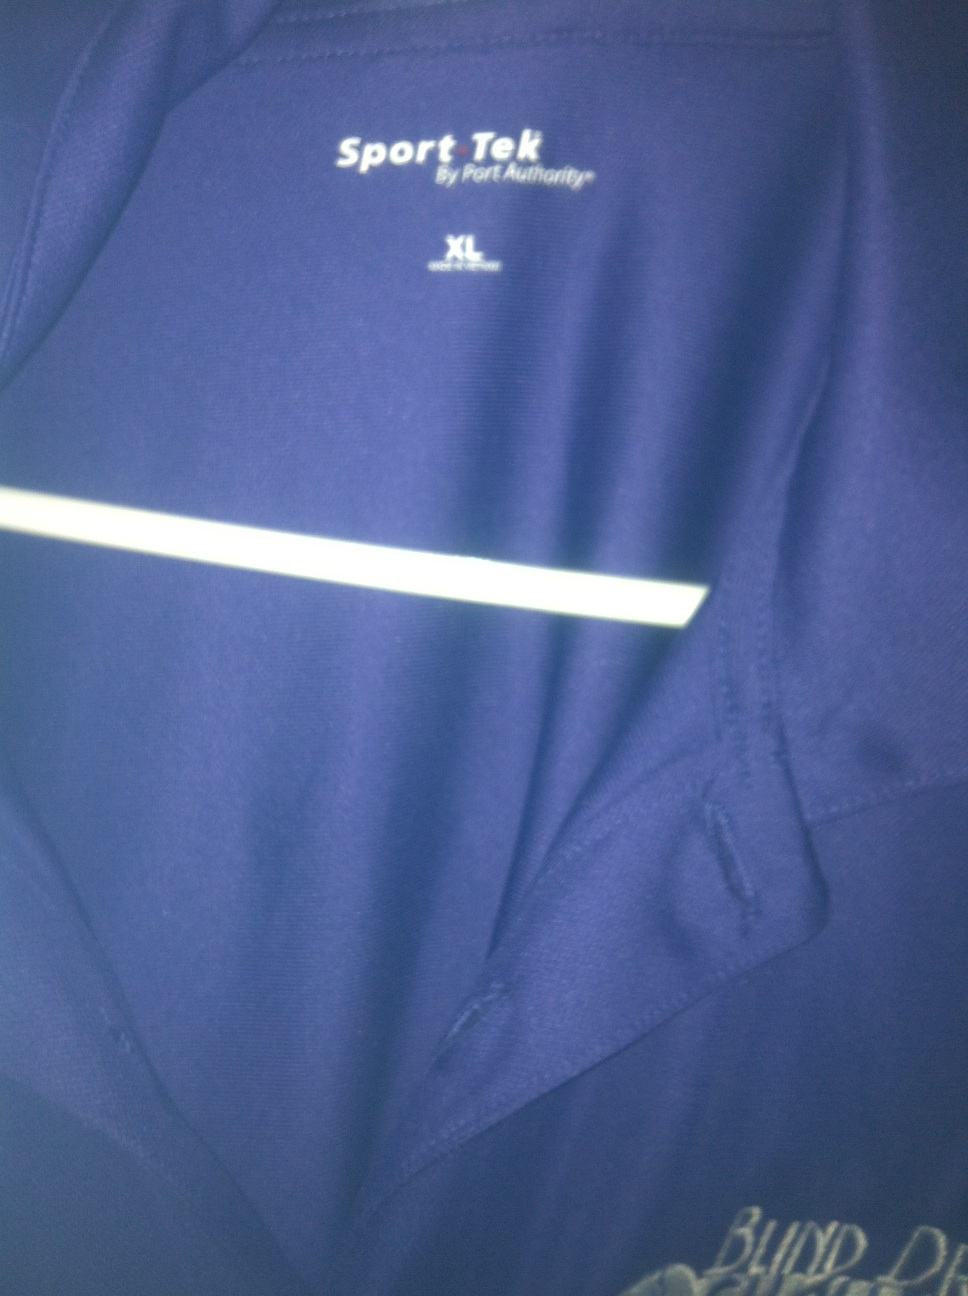What is this? This is a blue sports shirt by Sport Tek by Port Authority, size XL. The photo focuses on the upper left chest area, displaying part of the brand logo and a reflective stripe, characteristics typical of sportswear designed for visibility and brand recognition. 